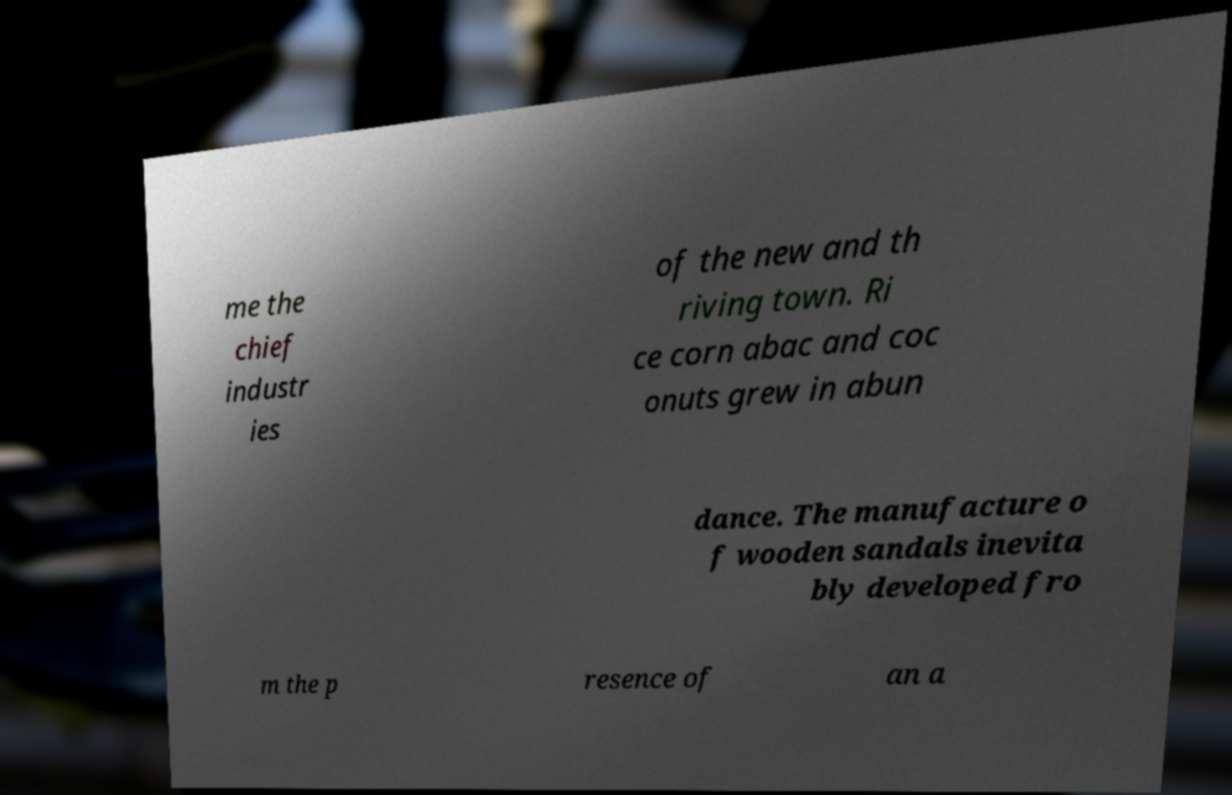Could you extract and type out the text from this image? me the chief industr ies of the new and th riving town. Ri ce corn abac and coc onuts grew in abun dance. The manufacture o f wooden sandals inevita bly developed fro m the p resence of an a 